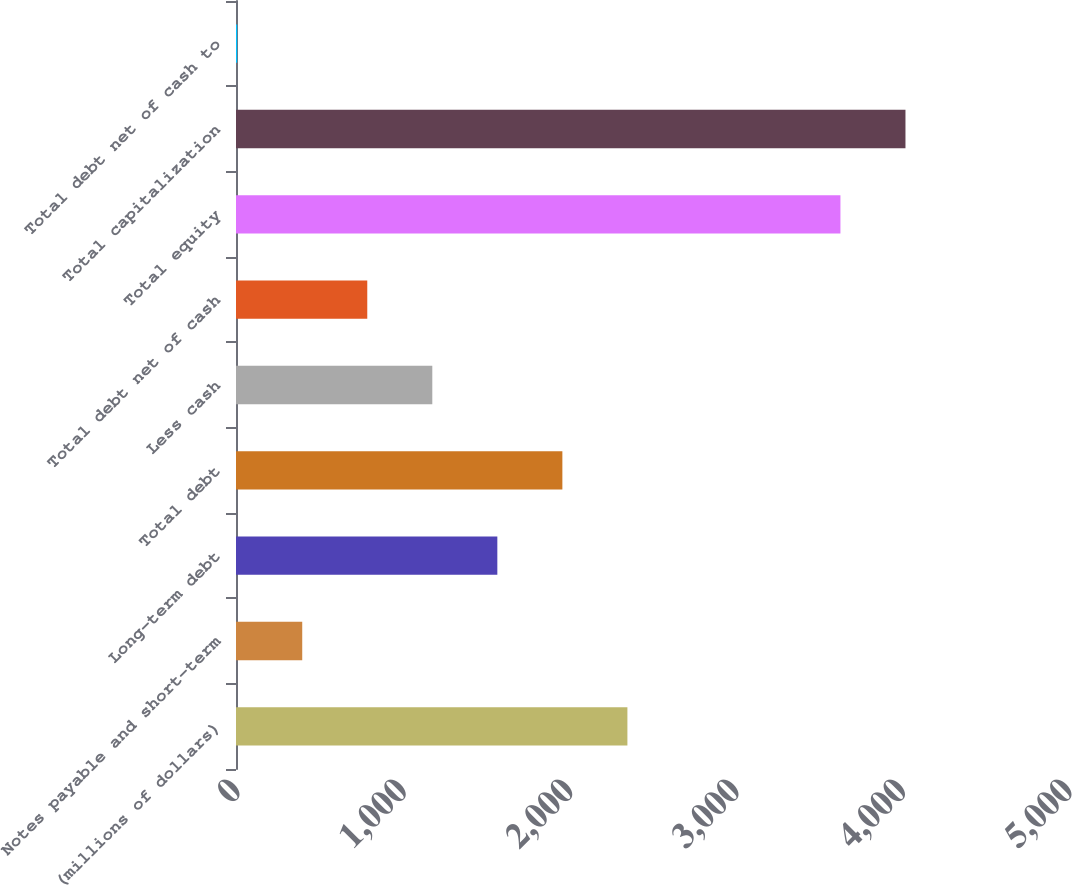<chart> <loc_0><loc_0><loc_500><loc_500><bar_chart><fcel>(millions of dollars)<fcel>Notes payable and short-term<fcel>Long-term debt<fcel>Total debt<fcel>Less cash<fcel>Total debt net of cash<fcel>Total equity<fcel>Total capitalization<fcel>Total debt net of cash to<nl><fcel>2352.18<fcel>398.03<fcel>1570.52<fcel>1961.35<fcel>1179.69<fcel>788.86<fcel>3632.4<fcel>4023.23<fcel>7.2<nl></chart> 